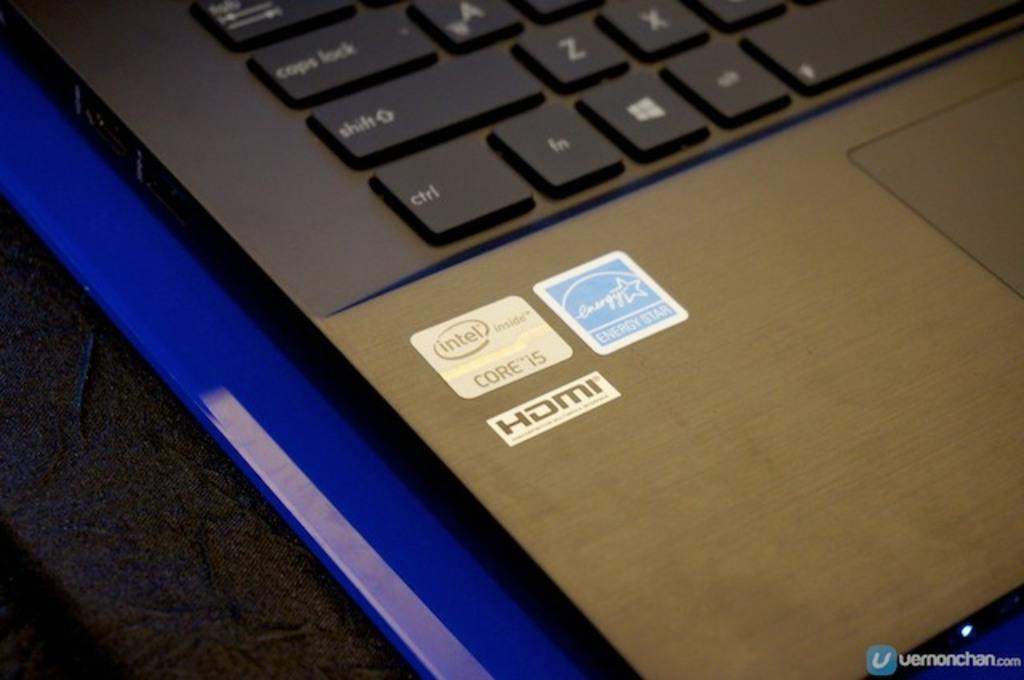<image>
Create a compact narrative representing the image presented. A HDMI laptop sits on a dark table 